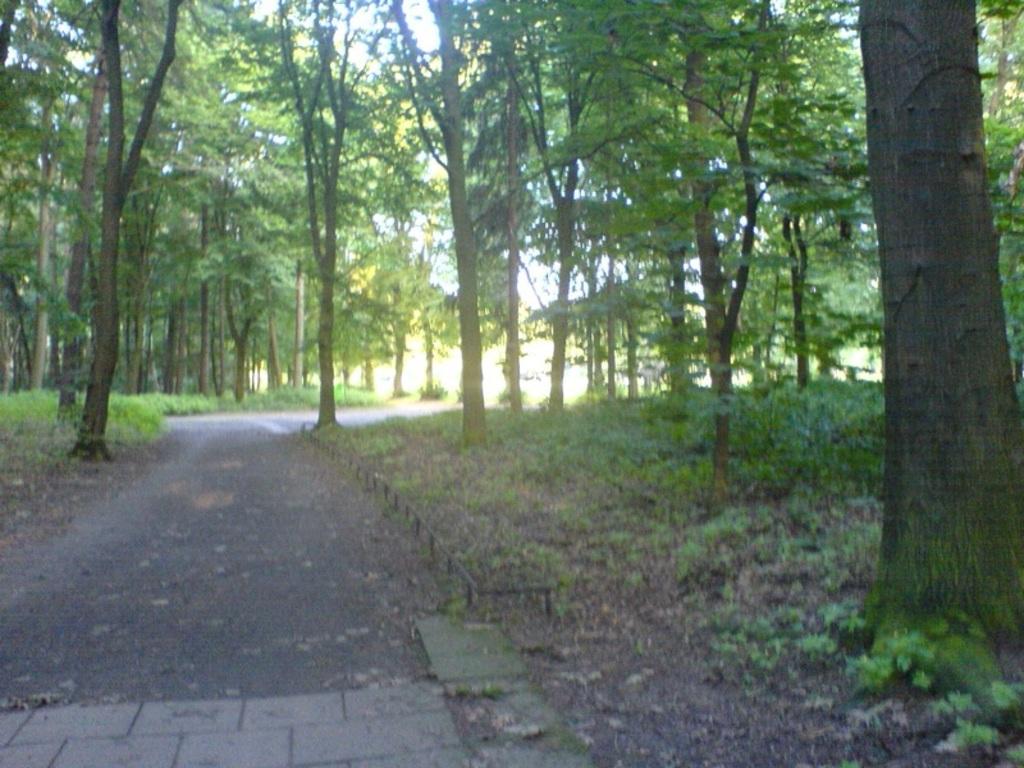Describe this image in one or two sentences. In this image I can see the road, few trees and few plants which are green in color and in the background I can see the sky. 